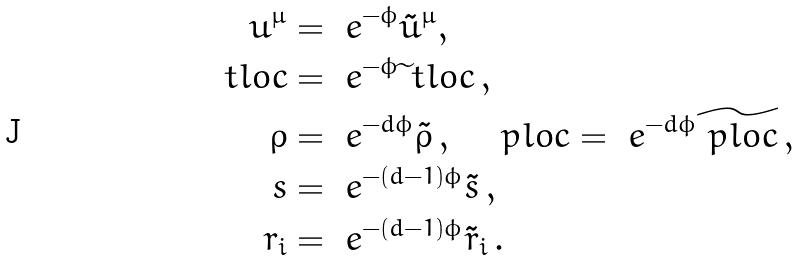<formula> <loc_0><loc_0><loc_500><loc_500>u ^ { \mu } & = \ e ^ { - \phi } \tilde { u } ^ { \mu } , \\ \ t l o c & = \ e ^ { - \phi } { \widetilde { \ } t l o c } \, , \\ \rho & = \ e ^ { - d \phi } { \tilde { \rho } } \, , \quad \ p l o c = \ e ^ { - d \phi } \widetilde { \ p l o c } \, , \\ s & = \ e ^ { - ( d - 1 ) \phi } { \tilde { s } } \, , \\ r _ { i } & = \ e ^ { - ( d - 1 ) \phi } { \tilde { r } _ { i } } \, .</formula> 